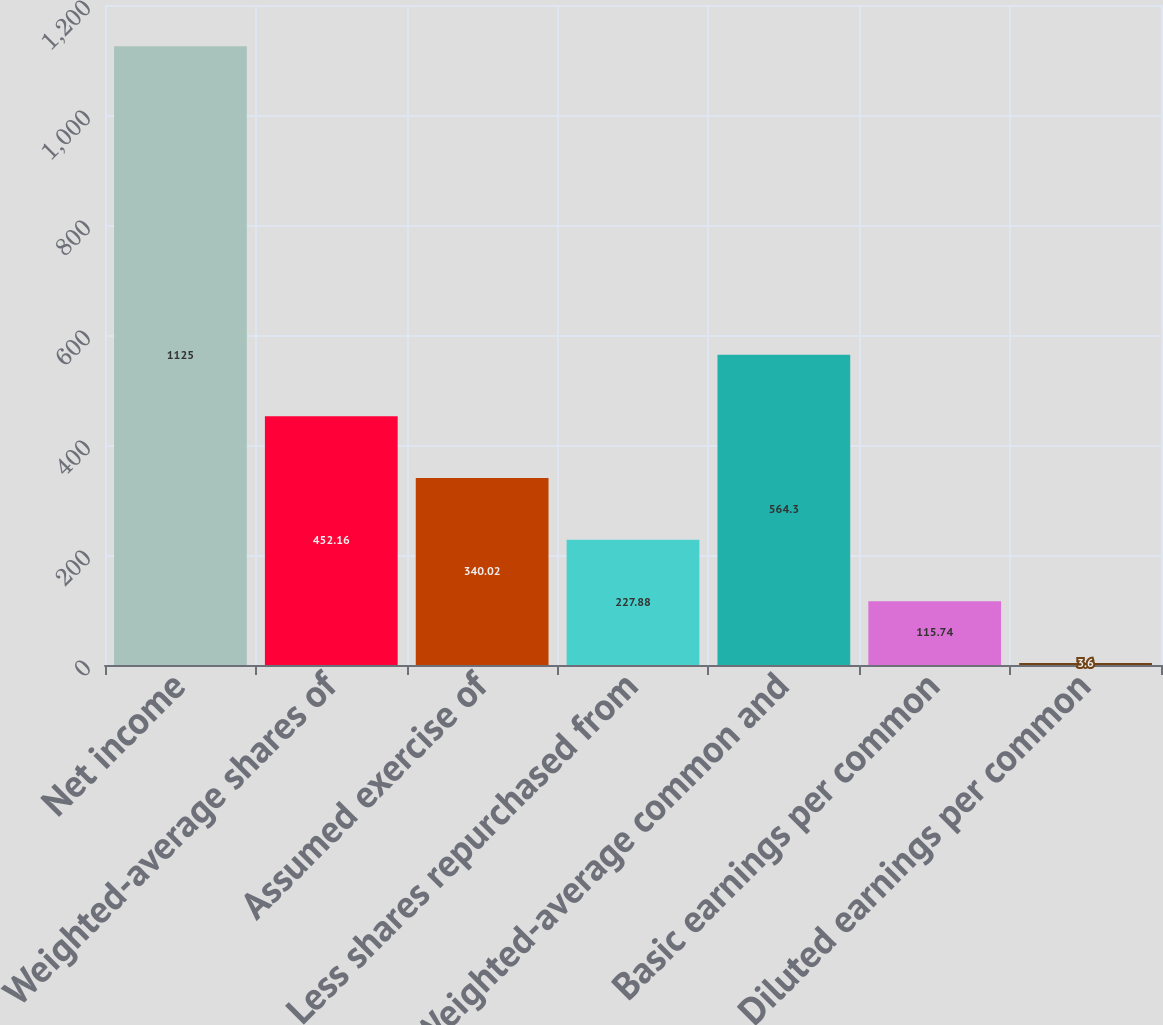Convert chart to OTSL. <chart><loc_0><loc_0><loc_500><loc_500><bar_chart><fcel>Net income<fcel>Weighted-average shares of<fcel>Assumed exercise of<fcel>Less shares repurchased from<fcel>Weighted-average common and<fcel>Basic earnings per common<fcel>Diluted earnings per common<nl><fcel>1125<fcel>452.16<fcel>340.02<fcel>227.88<fcel>564.3<fcel>115.74<fcel>3.6<nl></chart> 